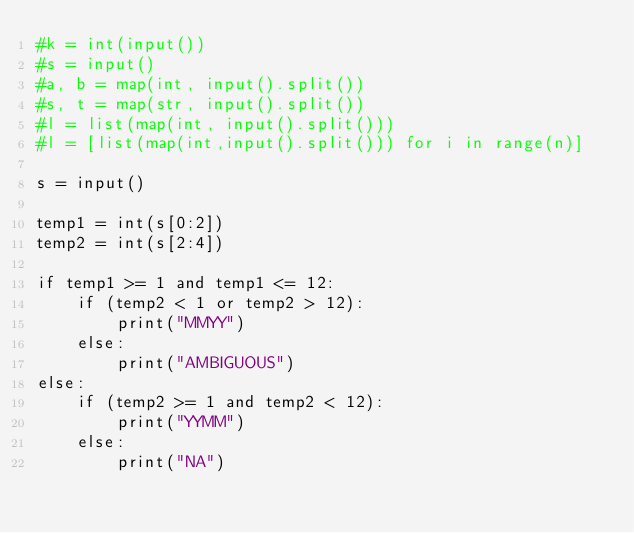Convert code to text. <code><loc_0><loc_0><loc_500><loc_500><_Python_>#k = int(input())
#s = input()
#a, b = map(int, input().split())
#s, t = map(str, input().split())
#l = list(map(int, input().split()))
#l = [list(map(int,input().split())) for i in range(n)]

s = input()

temp1 = int(s[0:2])
temp2 = int(s[2:4])

if temp1 >= 1 and temp1 <= 12:
    if (temp2 < 1 or temp2 > 12):
        print("MMYY")
    else:
        print("AMBIGUOUS")
else:
    if (temp2 >= 1 and temp2 < 12):
        print("YYMM")
    else:
        print("NA")
</code> 